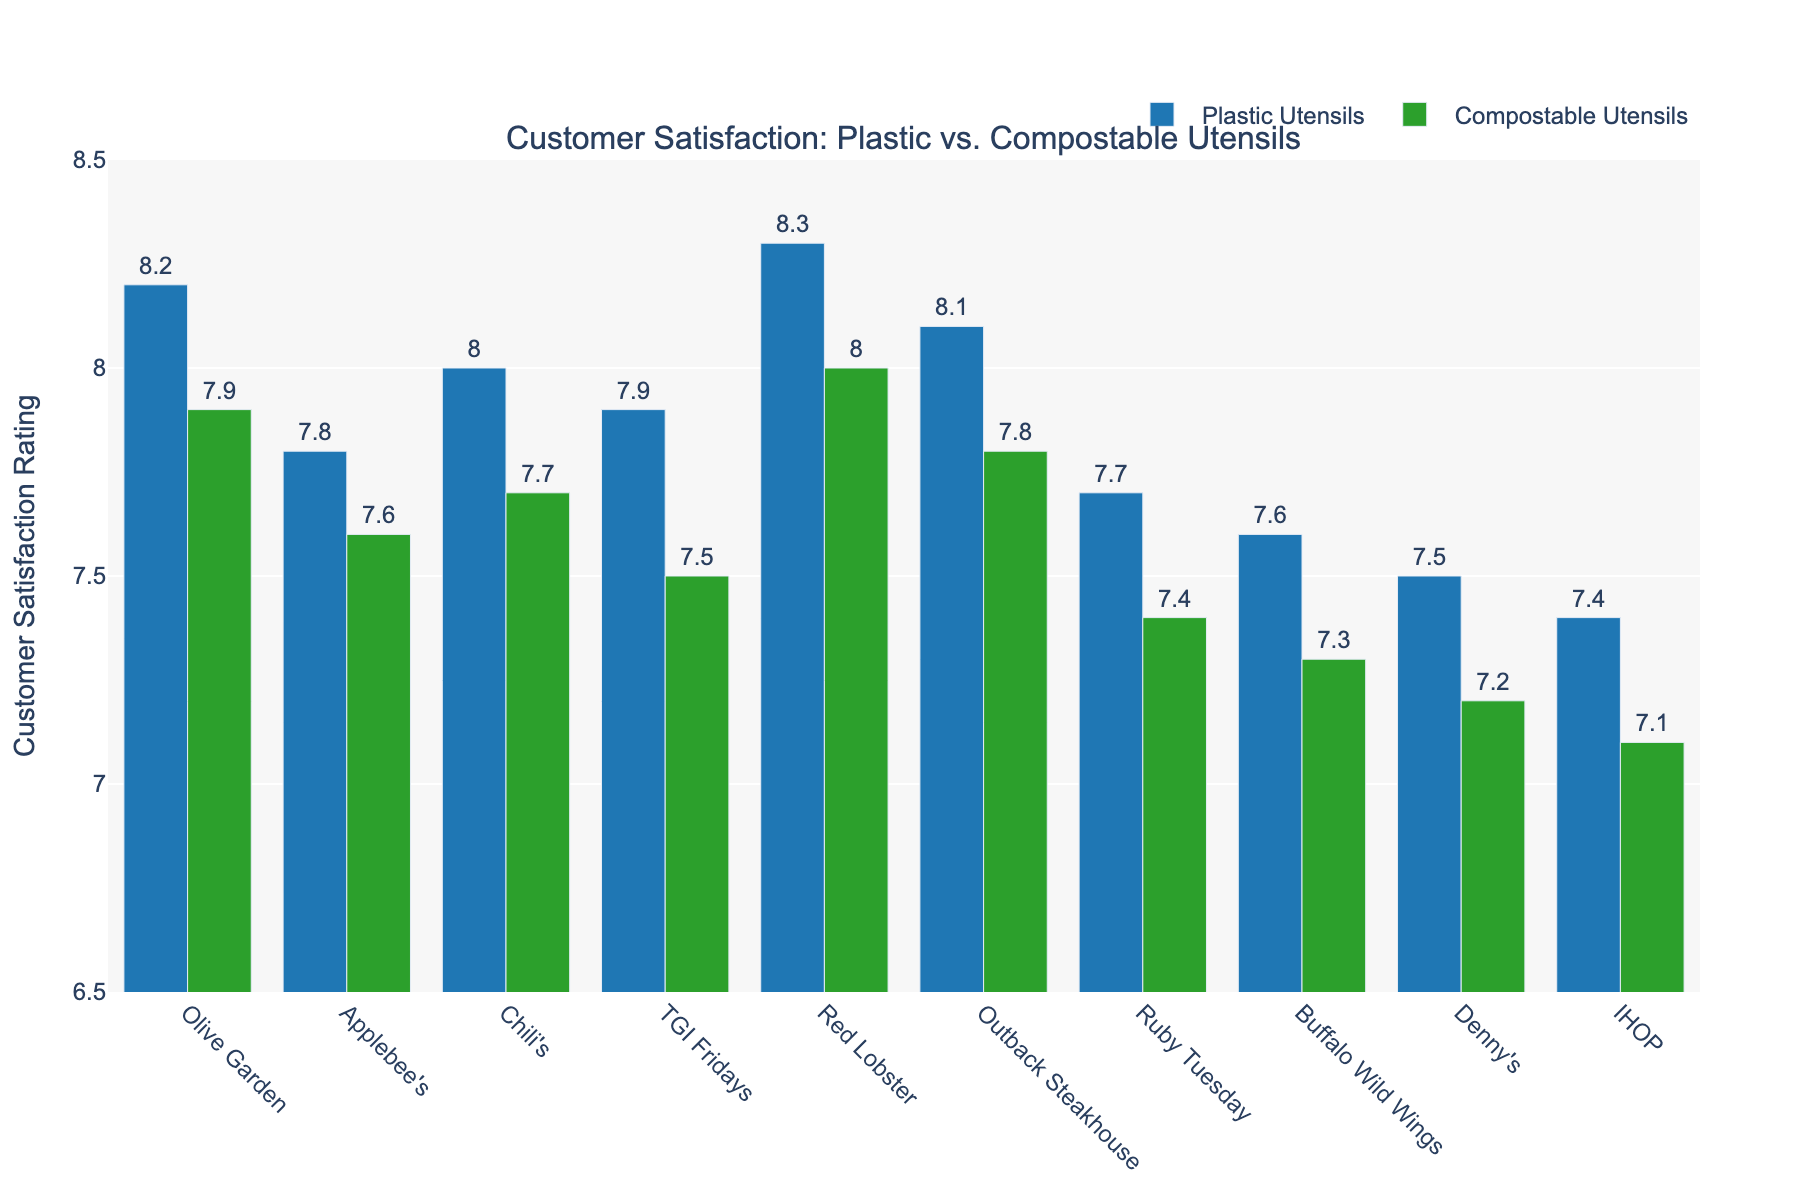What's the average customer satisfaction rating for restaurants using plastic utensils? Sum all the ratings for plastic utensils (8.2 + 7.8 + 8.0 + 7.9 + 8.3 + 8.1 + 7.7 + 7.6 + 7.5 + 7.4) = 78.5, then divide by the number of restaurants (10). The average rating is 78.5 / 10 = 7.85
Answer: 7.85 What's the average customer satisfaction rating for restaurants using compostable utensils? Sum all the ratings for compostable utensils (7.9 + 7.6 + 7.7 + 7.5 + 8.0 + 7.8 + 7.4 + 7.3 + 7.2 + 7.1) = 76.5, then divide by the number of restaurants (10). The average rating is 76.5 / 10 = 7.65
Answer: 7.65 Which restaurant has the largest difference in customer satisfaction ratings between plastic and compostable utensils? Calculate the difference for each restaurant and see which is the largest. For example, Olive Garden: 8.2 - 7.9 = 0.3, Applebee's: 7.8 - 7.6 = 0.2, etc. Red Lobster has the largest difference (8.3 - 8.0 = 0.3).
Answer: Red Lobster Is there any restaurant where the customer satisfaction rating for compostable utensils is higher than for plastic utensils? Compare each restaurant's ratings and see if any restaurant has a higher rating for compostable utensils. In this case, no restaurant has a higher rating for compostable utensils than plastic utensils.
Answer: No Which restaurant has the lowest customer satisfaction rating for plastic utensils? Examine all the bars for plastic utensils and identify the lowest value. IHOP has the lowest rating for plastic utensils with a score of 7.4.
Answer: IHOP What is the difference in average customer satisfaction ratings between restaurants using plastic and compostable utensils? Calculate the average ratings for both (plastic: 7.85, compostable: 7.65), then find the difference (7.85 - 7.65 = 0.2).
Answer: 0.2 How many restaurants have a customer satisfaction rating of 8.0 or higher using plastic utensils? Check each bar representing plastic utensils and count how many are 8.0 or higher (Olive Garden, Chili's, Red Lobster, and Outback Steakhouse).
Answer: 4 Compare the customer satisfaction ratings of Olive Garden and Applebee's for both types of utensils. Which has the higher satisfaction for each type? For Plastic Utensils: Olive Garden (8.2) vs. Applebee's (7.8). Olive Garden has higher. For Compostable Utensils: Olive Garden (7.9) vs. Applebee's (7.6). Olive Garden has higher.
Answer: Olive Garden for both What is the average customer satisfaction rating for Olive Garden, Applebee's, and Chili's using compostable utensils? Sum the ratings for Olive Garden, Applebee's, and Chili's (7.9 + 7.6 + 7.7) = 23.2, then divide by the number of restaurants (3). The average rating is 23.2 / 3 = 7.73
Answer: 7.73 